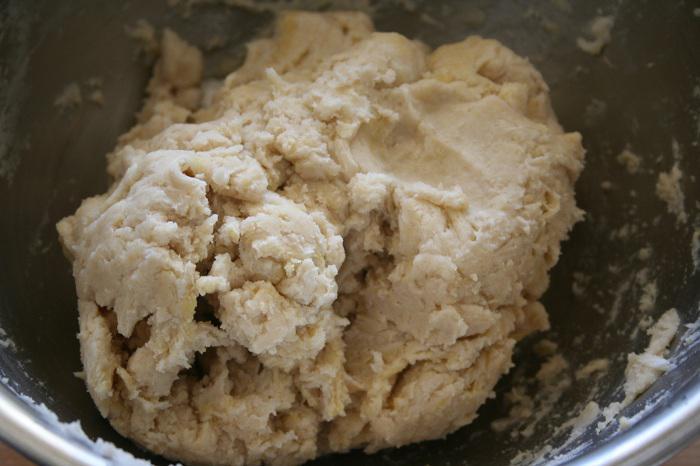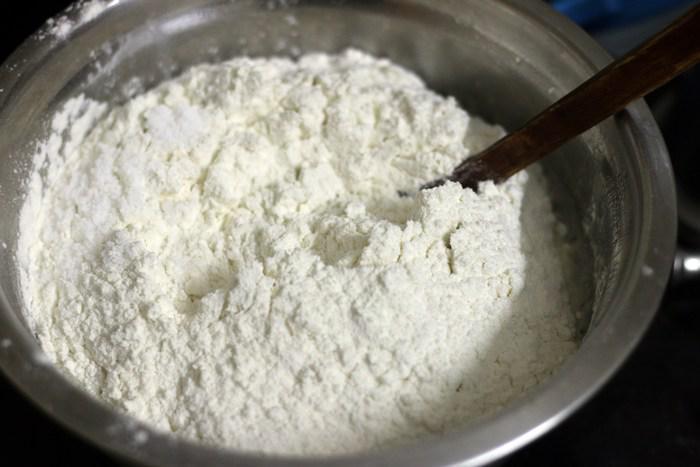The first image is the image on the left, the second image is the image on the right. Given the left and right images, does the statement "In at least one image there is a utenical in a silver mixing bowl." hold true? Answer yes or no. Yes. The first image is the image on the left, the second image is the image on the right. For the images shown, is this caption "There is a utensil in some dough." true? Answer yes or no. Yes. 